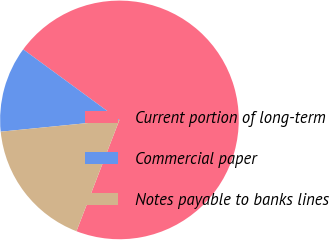Convert chart to OTSL. <chart><loc_0><loc_0><loc_500><loc_500><pie_chart><fcel>Current portion of long-term<fcel>Commercial paper<fcel>Notes payable to banks lines<nl><fcel>70.8%<fcel>11.64%<fcel>17.56%<nl></chart> 